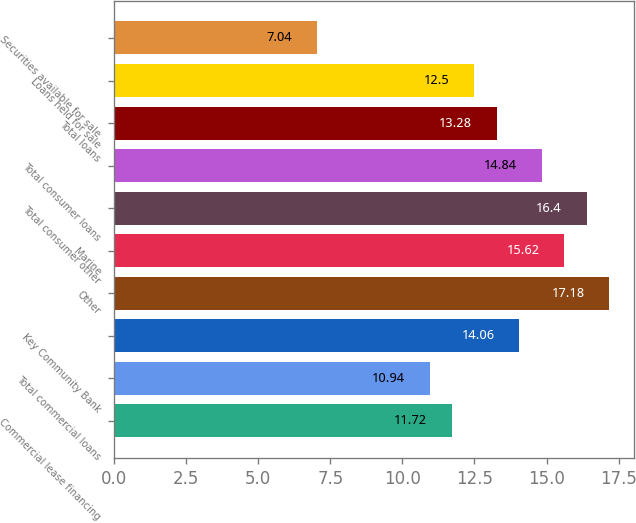Convert chart. <chart><loc_0><loc_0><loc_500><loc_500><bar_chart><fcel>Commercial lease financing<fcel>Total commercial loans<fcel>Key Community Bank<fcel>Other<fcel>Marine<fcel>Total consumer other<fcel>Total consumer loans<fcel>Total loans<fcel>Loans held for sale<fcel>Securities available for sale<nl><fcel>11.72<fcel>10.94<fcel>14.06<fcel>17.18<fcel>15.62<fcel>16.4<fcel>14.84<fcel>13.28<fcel>12.5<fcel>7.04<nl></chart> 